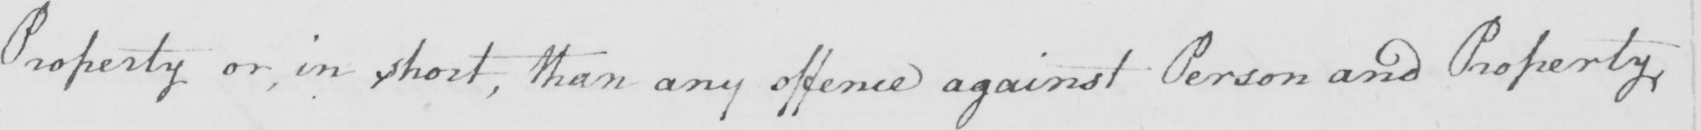Can you tell me what this handwritten text says? Property or , in short , than any offence against Person and Property 